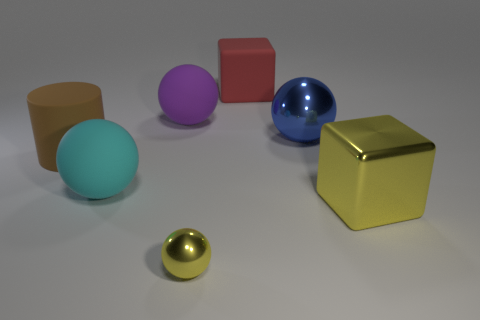Is there anything else that is the same size as the yellow ball?
Keep it short and to the point. No. The large object that is in front of the big brown rubber thing and right of the cyan matte ball has what shape?
Offer a terse response. Cube. Are there any spheres that are to the right of the yellow shiny object that is to the left of the large block in front of the big brown cylinder?
Offer a very short reply. Yes. How many other things are the same material as the big cyan thing?
Provide a short and direct response. 3. What number of yellow cubes are there?
Provide a succinct answer. 1. How many things are tiny gray matte spheres or large spheres to the right of the tiny yellow ball?
Make the answer very short. 1. Are there any other things that are the same shape as the large blue object?
Your answer should be very brief. Yes. Do the ball that is behind the blue thing and the big rubber cylinder have the same size?
Offer a very short reply. Yes. How many shiny things are big brown things or tiny brown cylinders?
Make the answer very short. 0. There is a object left of the cyan rubber object; what size is it?
Your response must be concise. Large. 